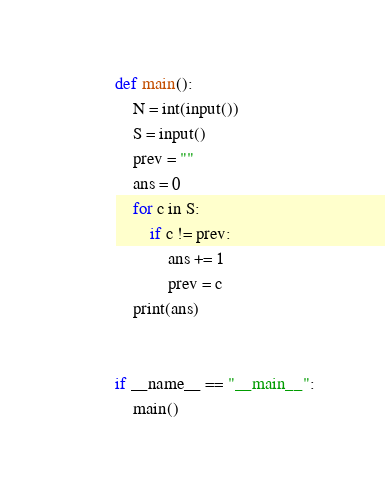<code> <loc_0><loc_0><loc_500><loc_500><_Python_>def main():
    N = int(input())
    S = input()
    prev = ""
    ans = 0
    for c in S:
        if c != prev:
            ans += 1
            prev = c
    print(ans)


if __name__ == "__main__":
    main()
</code> 